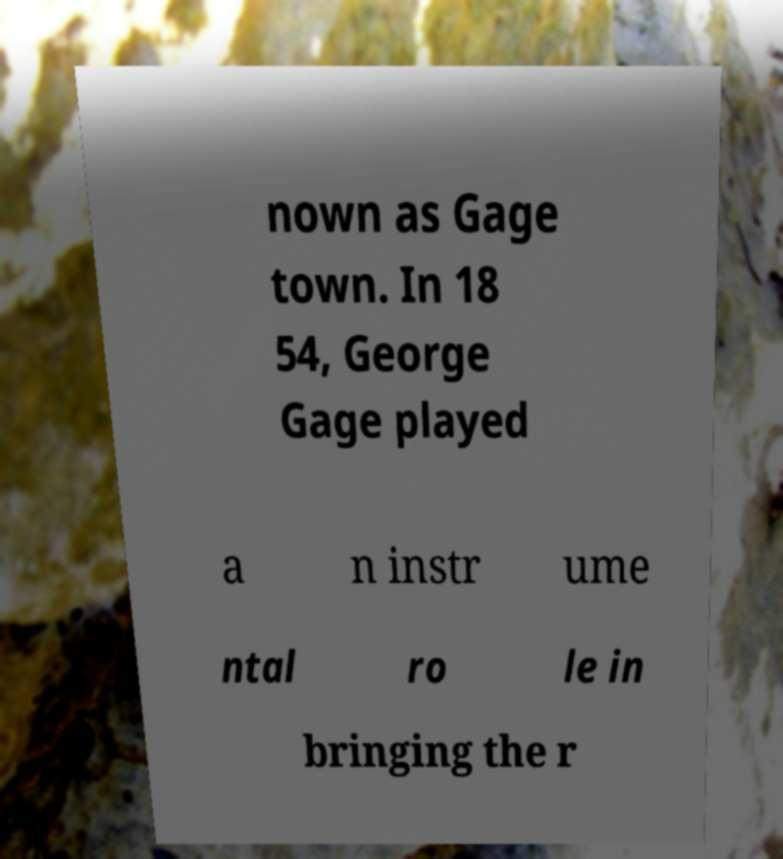Please identify and transcribe the text found in this image. nown as Gage town. In 18 54, George Gage played a n instr ume ntal ro le in bringing the r 